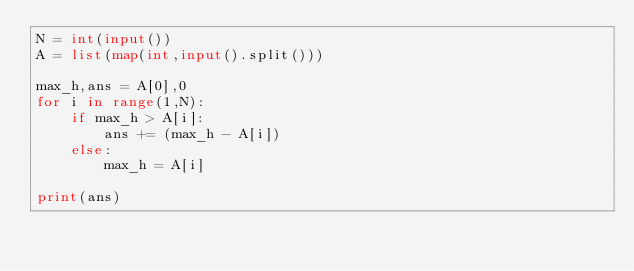Convert code to text. <code><loc_0><loc_0><loc_500><loc_500><_Python_>N = int(input())
A = list(map(int,input().split()))

max_h,ans = A[0],0
for i in range(1,N):
    if max_h > A[i]:
        ans += (max_h - A[i])
    else:
        max_h = A[i]

print(ans)
</code> 